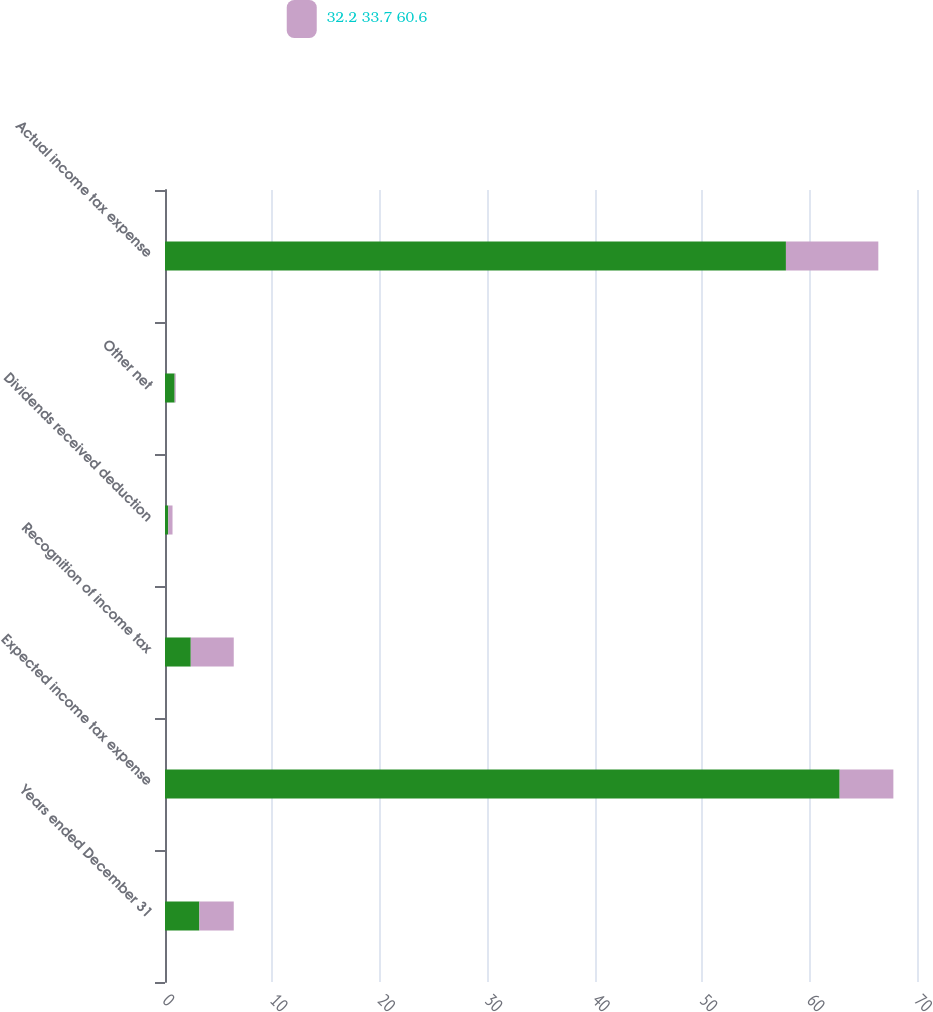<chart> <loc_0><loc_0><loc_500><loc_500><stacked_bar_chart><ecel><fcel>Years ended December 31<fcel>Expected income tax expense<fcel>Recognition of income tax<fcel>Dividends received deduction<fcel>Other net<fcel>Actual income tax expense<nl><fcel>nan<fcel>3.2<fcel>62.8<fcel>2.4<fcel>0.3<fcel>0.9<fcel>57.8<nl><fcel>32.2 33.7 60.6<fcel>3.2<fcel>5<fcel>4<fcel>0.4<fcel>0.1<fcel>8.6<nl></chart> 